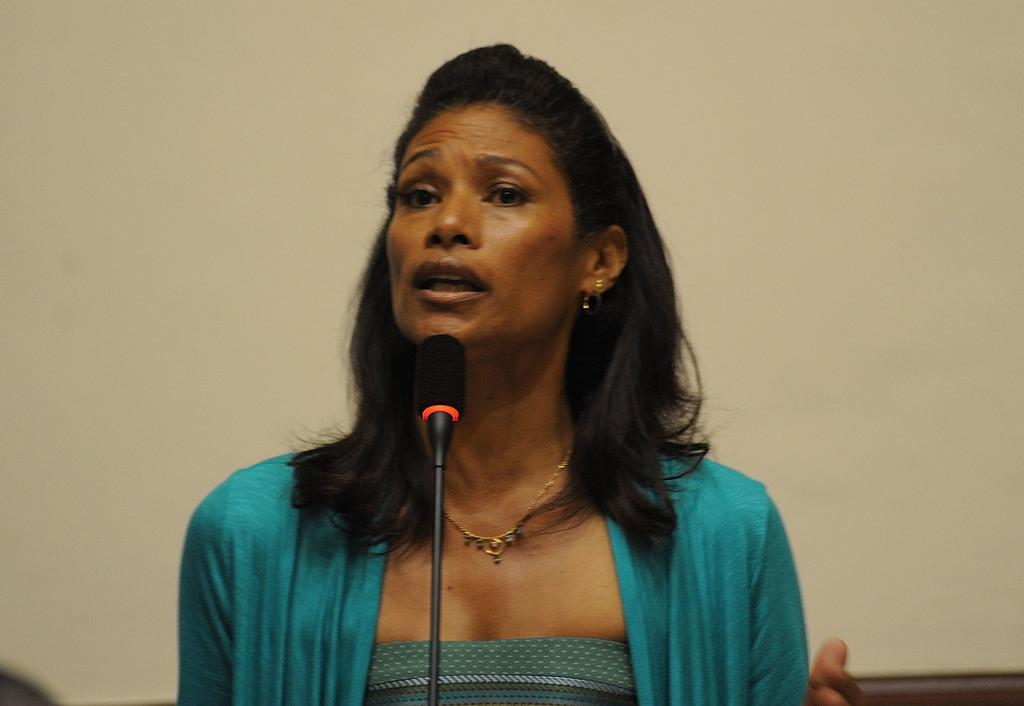Who is the main subject in the image? There is a lady in the image. What is the lady wearing? The lady is wearing a green dress. Are there any accessories visible on the lady? Yes, the lady has a chain around her neck. What object is in front of the lady? There is a microphone in front of her. What can be seen behind the lady? There is a wall behind her. What type of button does the lady need to press to increase her pleasure in the image? There is no button or indication of pleasure in the image; it simply shows a lady with a microphone in front of her. 